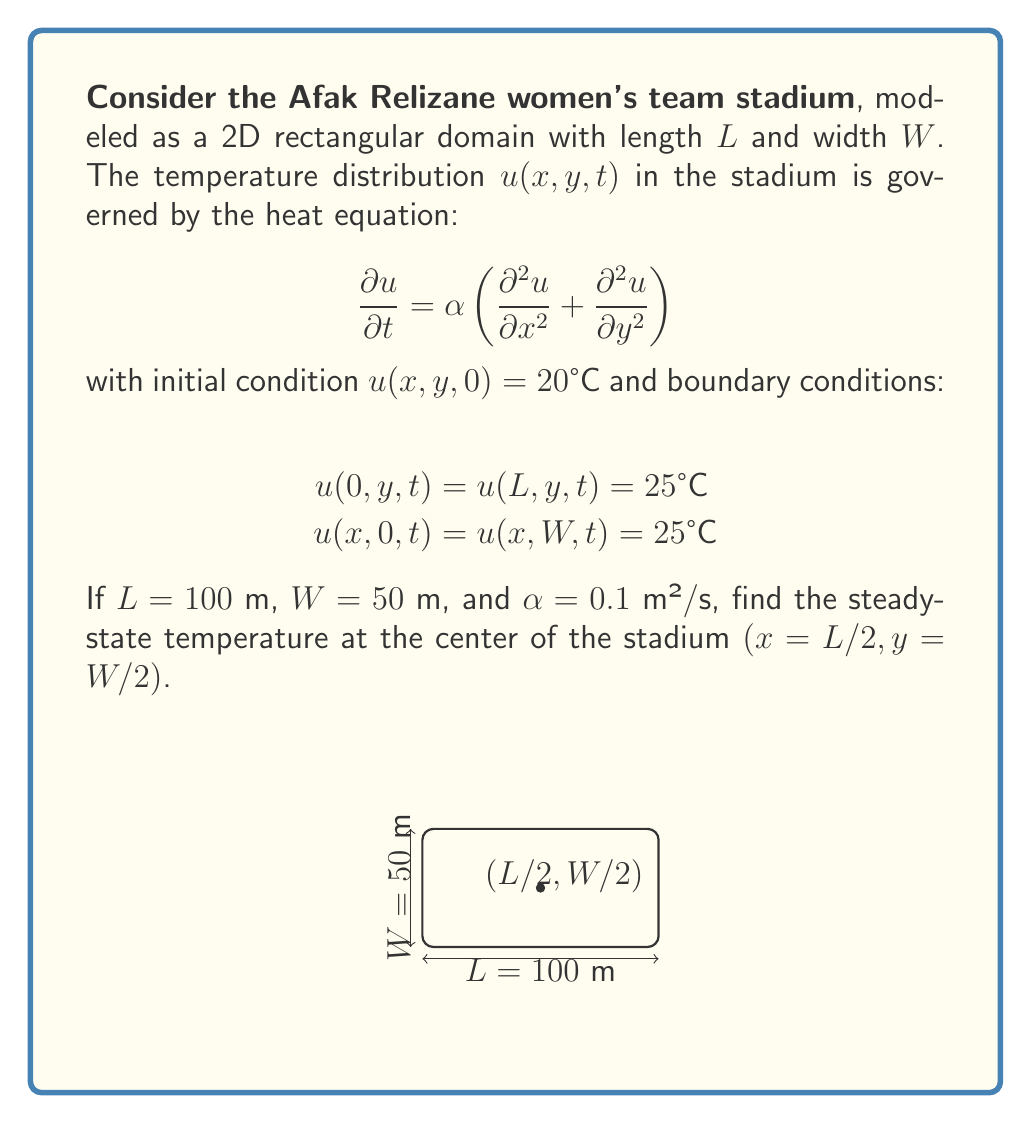Can you solve this math problem? To solve this problem, we'll follow these steps:

1) For the steady-state solution, $\frac{\partial u}{\partial t} = 0$, so the heat equation reduces to:

   $$\frac{\partial^2 u}{\partial x^2} + \frac{\partial^2 u}{\partial y^2} = 0$$

2) Given the symmetry of the problem, we can use the method of separation of variables. Let $u(x,y) = X(x)Y(y)$.

3) Substituting this into the equation:

   $$X''(x)Y(y) + X(x)Y''(y) = 0$$

4) Dividing by $X(x)Y(y)$:

   $$\frac{X''(x)}{X(x)} + \frac{Y''(y)}{Y(y)} = 0$$

5) This equation is satisfied if both terms are equal to a constant, say $-\lambda^2$:

   $$\frac{X''(x)}{X(x)} = -\lambda^2, \quad \frac{Y''(y)}{Y(y)} = -\lambda^2$$

6) The general solutions are:

   $$X(x) = A\cos(\lambda x) + B\sin(\lambda x)$$
   $$Y(y) = C\cos(\lambda y) + D\sin(\lambda y)$$

7) Applying the boundary conditions:

   $$u(0,y) = u(L,y) = 25°C \implies X(0) = X(L) = 25$$
   $$u(x,0) = u(x,W) = 25°C \implies Y(0) = Y(W) = 25$$

8) This leads to:

   $$X(x) = 25\left(1 - \frac{4}{\pi}\sum_{n\text{ odd}}\frac{1}{n}\sin\left(\frac{n\pi x}{L}\right)\right)$$
   $$Y(y) = 25\left(1 - \frac{4}{\pi}\sum_{m\text{ odd}}\frac{1}{m}\sin\left(\frac{m\pi y}{W}\right)\right)$$

9) The complete solution is:

   $$u(x,y) = 25\left(1 - \frac{4}{\pi}\sum_{n\text{ odd}}\frac{1}{n}\sin\left(\frac{n\pi x}{L}\right)\right)\left(1 - \frac{4}{\pi}\sum_{m\text{ odd}}\frac{1}{m}\sin\left(\frac{m\pi y}{W}\right)\right)$$

10) At the center of the stadium $(x = L/2, y = W/2)$:

    $$u(L/2, W/2) = 25\left(1 - \frac{4}{\pi}\sum_{n\text{ odd}}\frac{1}{n}\sin\left(\frac{n\pi}{2}\right)\right)\left(1 - \frac{4}{\pi}\sum_{m\text{ odd}}\frac{1}{m}\sin\left(\frac{m\pi}{2}\right)\right)$$

11) Note that $\sin\left(\frac{n\pi}{2}\right) = 0$ for even $n$ and $(-1)^{(n-1)/2}$ for odd $n$. The same applies for $m$.

12) Evaluating the series (taking the first few terms for approximation):

    $$u(L/2, W/2) \approx 25(1 - 0.9003)(1 - 0.9003) = 25 \cdot 0.0997 \cdot 0.0997 \approx 0.2481°C$$
Answer: $0.2481°C$ 